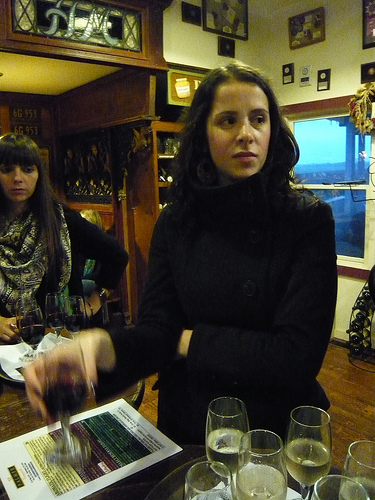<image>
Can you confirm if the window is behind the woman? Yes. From this viewpoint, the window is positioned behind the woman, with the woman partially or fully occluding the window. Where is the women in relation to the women? Is it to the right of the women? Yes. From this viewpoint, the women is positioned to the right side relative to the women. 